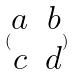Convert formula to latex. <formula><loc_0><loc_0><loc_500><loc_500>( \begin{matrix} a & b \\ c & d \end{matrix} )</formula> 